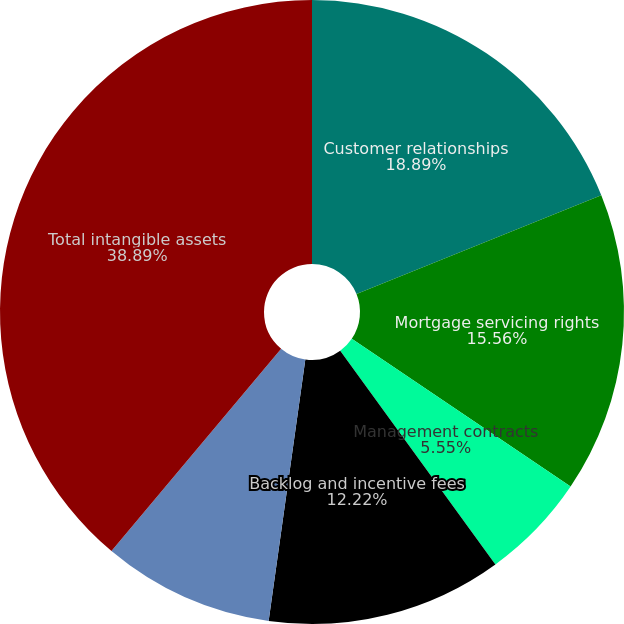Convert chart to OTSL. <chart><loc_0><loc_0><loc_500><loc_500><pie_chart><fcel>Customer relationships<fcel>Mortgage servicing rights<fcel>Management contracts<fcel>Backlog and incentive fees<fcel>Other<fcel>Total intangible assets<nl><fcel>18.89%<fcel>15.56%<fcel>5.55%<fcel>12.22%<fcel>8.89%<fcel>38.89%<nl></chart> 